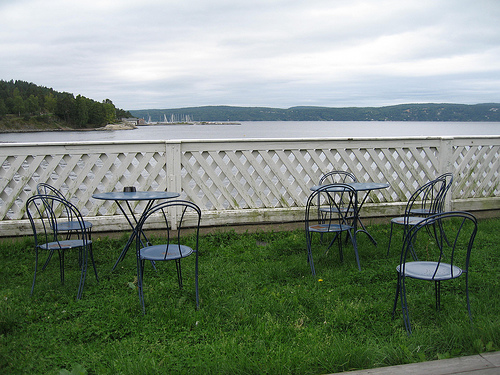<image>
Is there a table behind the chair? Yes. From this viewpoint, the table is positioned behind the chair, with the chair partially or fully occluding the table. Is there a fence behind the table? Yes. From this viewpoint, the fence is positioned behind the table, with the table partially or fully occluding the fence. 